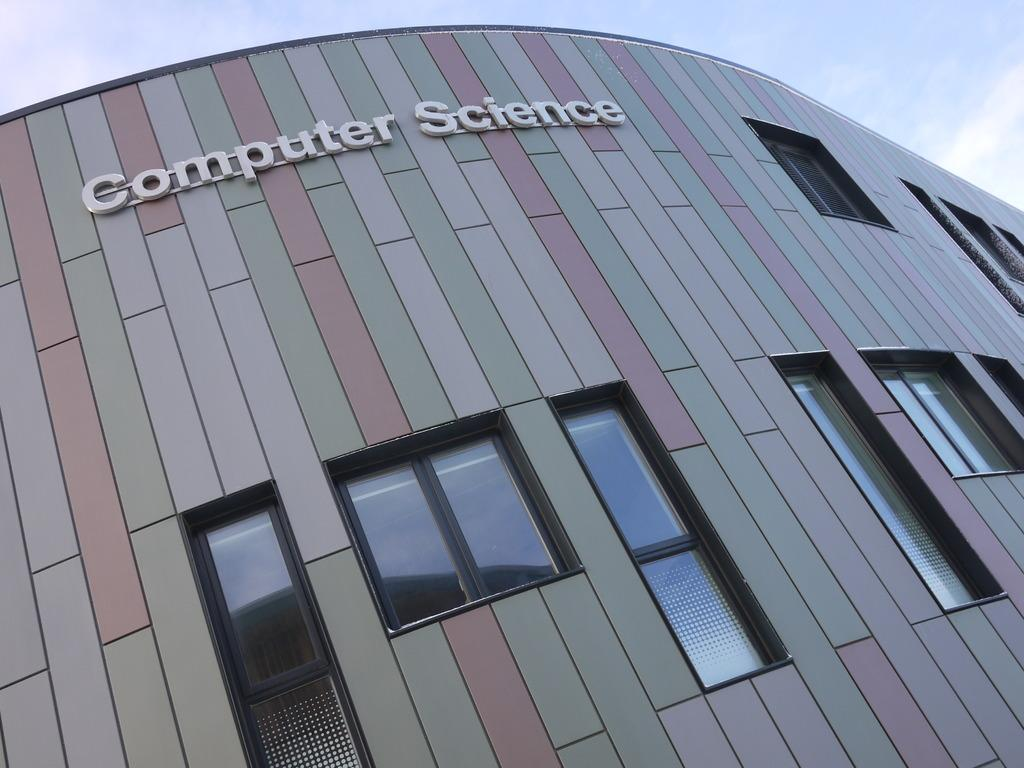What is the main structure in the image? There is a building in the image. What feature can be seen on the building? The building has a group of windows. Is there any text on the building? Yes, there is text on the building. What can be seen in the background of the image? The sky is visible in the background of the image. How would you describe the sky in the image? The sky appears to be cloudy. Can you see a woman holding a gun and a sack in the image? No, there is no woman, gun, or sack present in the image. 